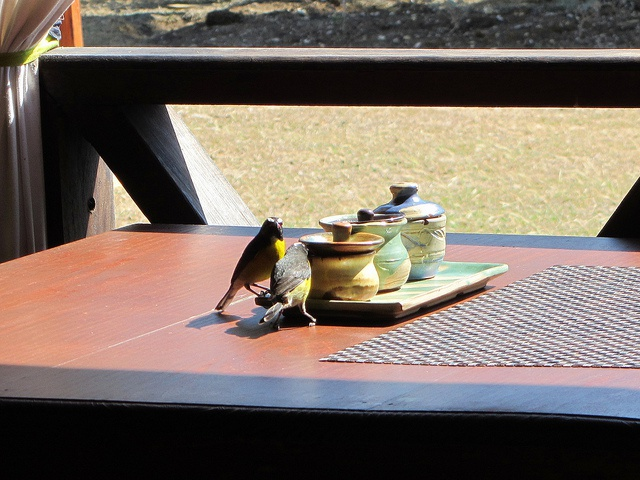Describe the objects in this image and their specific colors. I can see dining table in lightgray, lightpink, salmon, and darkgray tones, bird in lightgray, black, maroon, and gold tones, and bird in lightgray, darkgray, black, and khaki tones in this image. 